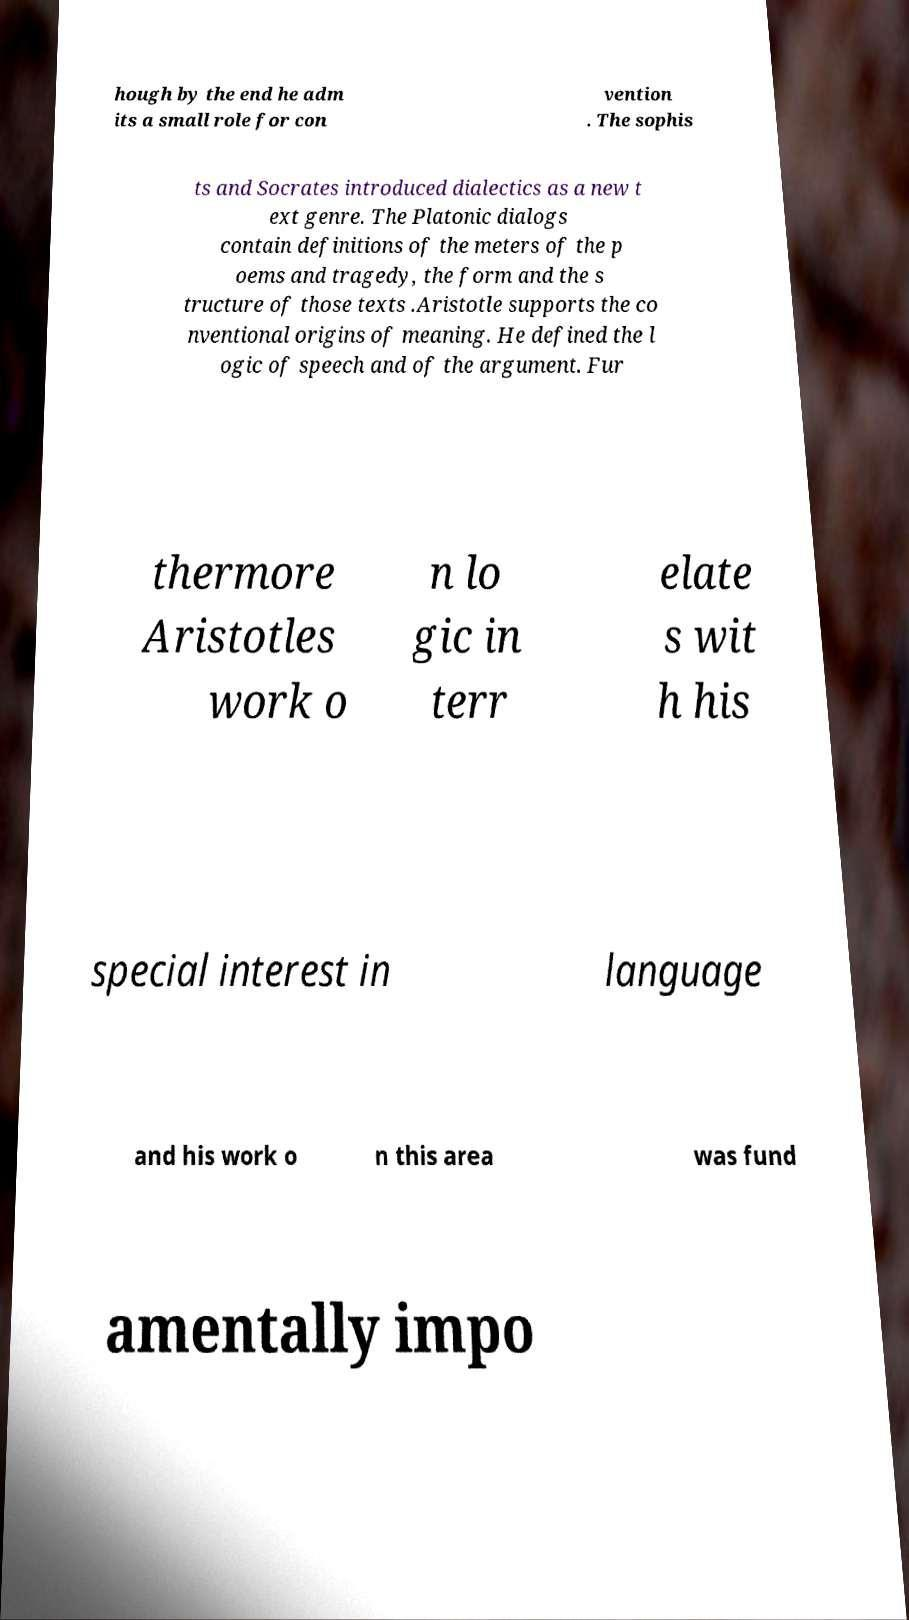I need the written content from this picture converted into text. Can you do that? hough by the end he adm its a small role for con vention . The sophis ts and Socrates introduced dialectics as a new t ext genre. The Platonic dialogs contain definitions of the meters of the p oems and tragedy, the form and the s tructure of those texts .Aristotle supports the co nventional origins of meaning. He defined the l ogic of speech and of the argument. Fur thermore Aristotles work o n lo gic in terr elate s wit h his special interest in language and his work o n this area was fund amentally impo 